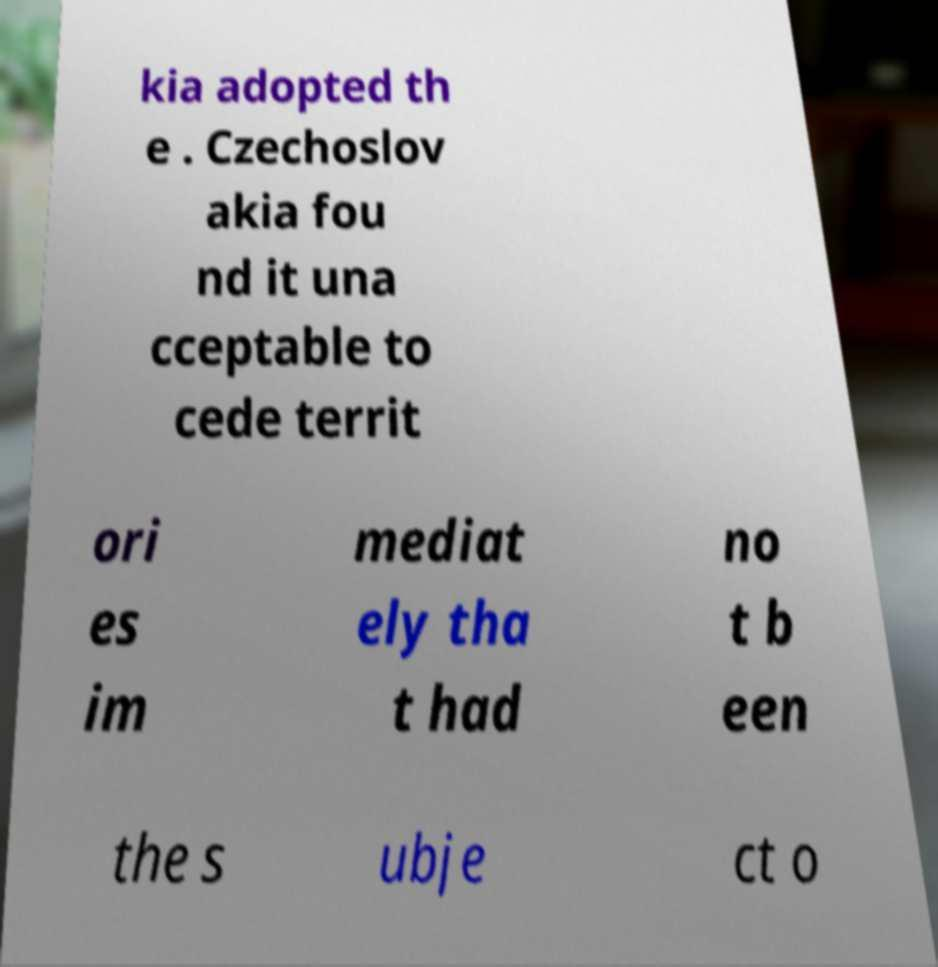Can you read and provide the text displayed in the image?This photo seems to have some interesting text. Can you extract and type it out for me? kia adopted th e . Czechoslov akia fou nd it una cceptable to cede territ ori es im mediat ely tha t had no t b een the s ubje ct o 